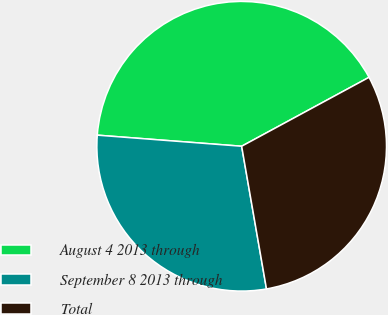Convert chart to OTSL. <chart><loc_0><loc_0><loc_500><loc_500><pie_chart><fcel>August 4 2013 through<fcel>September 8 2013 through<fcel>Total<nl><fcel>40.88%<fcel>28.96%<fcel>30.15%<nl></chart> 